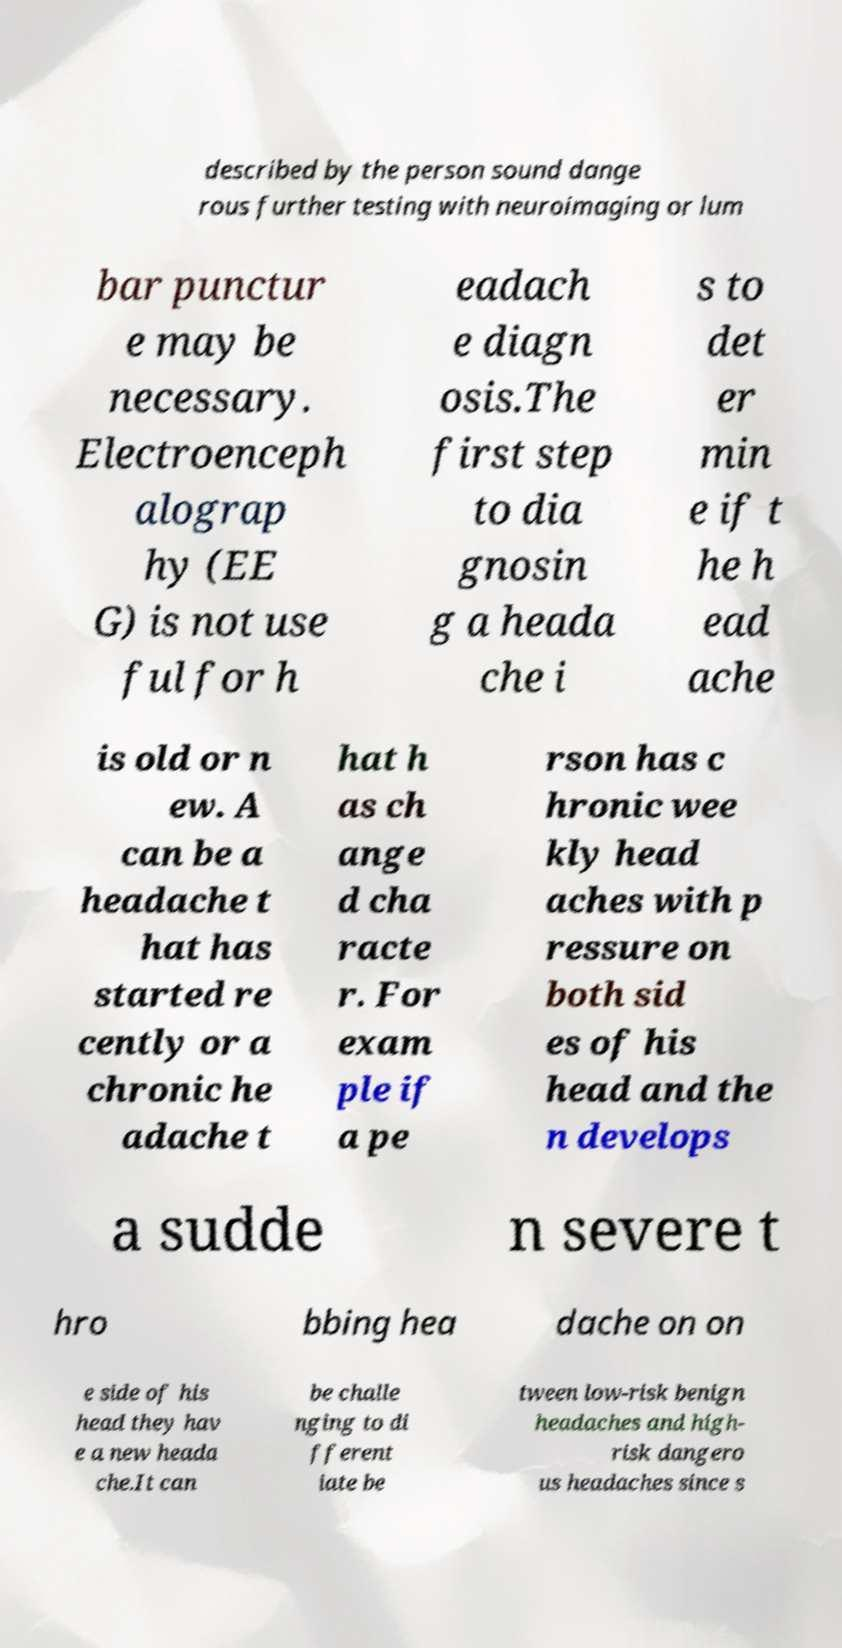Please read and relay the text visible in this image. What does it say? described by the person sound dange rous further testing with neuroimaging or lum bar punctur e may be necessary. Electroenceph alograp hy (EE G) is not use ful for h eadach e diagn osis.The first step to dia gnosin g a heada che i s to det er min e if t he h ead ache is old or n ew. A can be a headache t hat has started re cently or a chronic he adache t hat h as ch ange d cha racte r. For exam ple if a pe rson has c hronic wee kly head aches with p ressure on both sid es of his head and the n develops a sudde n severe t hro bbing hea dache on on e side of his head they hav e a new heada che.It can be challe nging to di fferent iate be tween low-risk benign headaches and high- risk dangero us headaches since s 